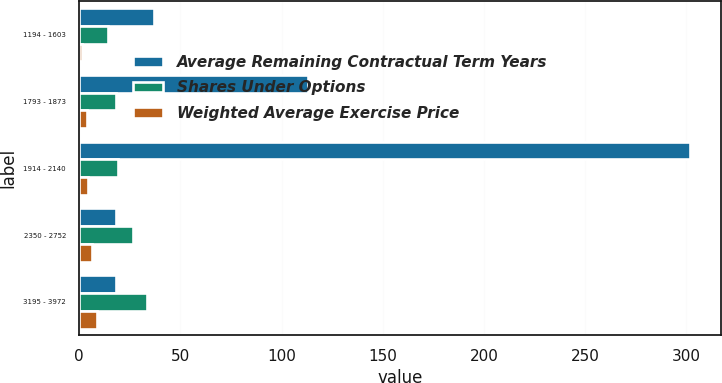Convert chart to OTSL. <chart><loc_0><loc_0><loc_500><loc_500><stacked_bar_chart><ecel><fcel>1194 - 1603<fcel>1793 - 1873<fcel>1914 - 2140<fcel>2350 - 2752<fcel>3195 - 3972<nl><fcel>Average Remaining Contractual Term Years<fcel>37<fcel>113<fcel>302<fcel>18.35<fcel>18.35<nl><fcel>Shares Under Options<fcel>14.09<fcel>18.35<fcel>19.15<fcel>26.64<fcel>33.59<nl><fcel>Weighted Average Exercise Price<fcel>1.5<fcel>3.8<fcel>4.3<fcel>6.2<fcel>8.9<nl></chart> 